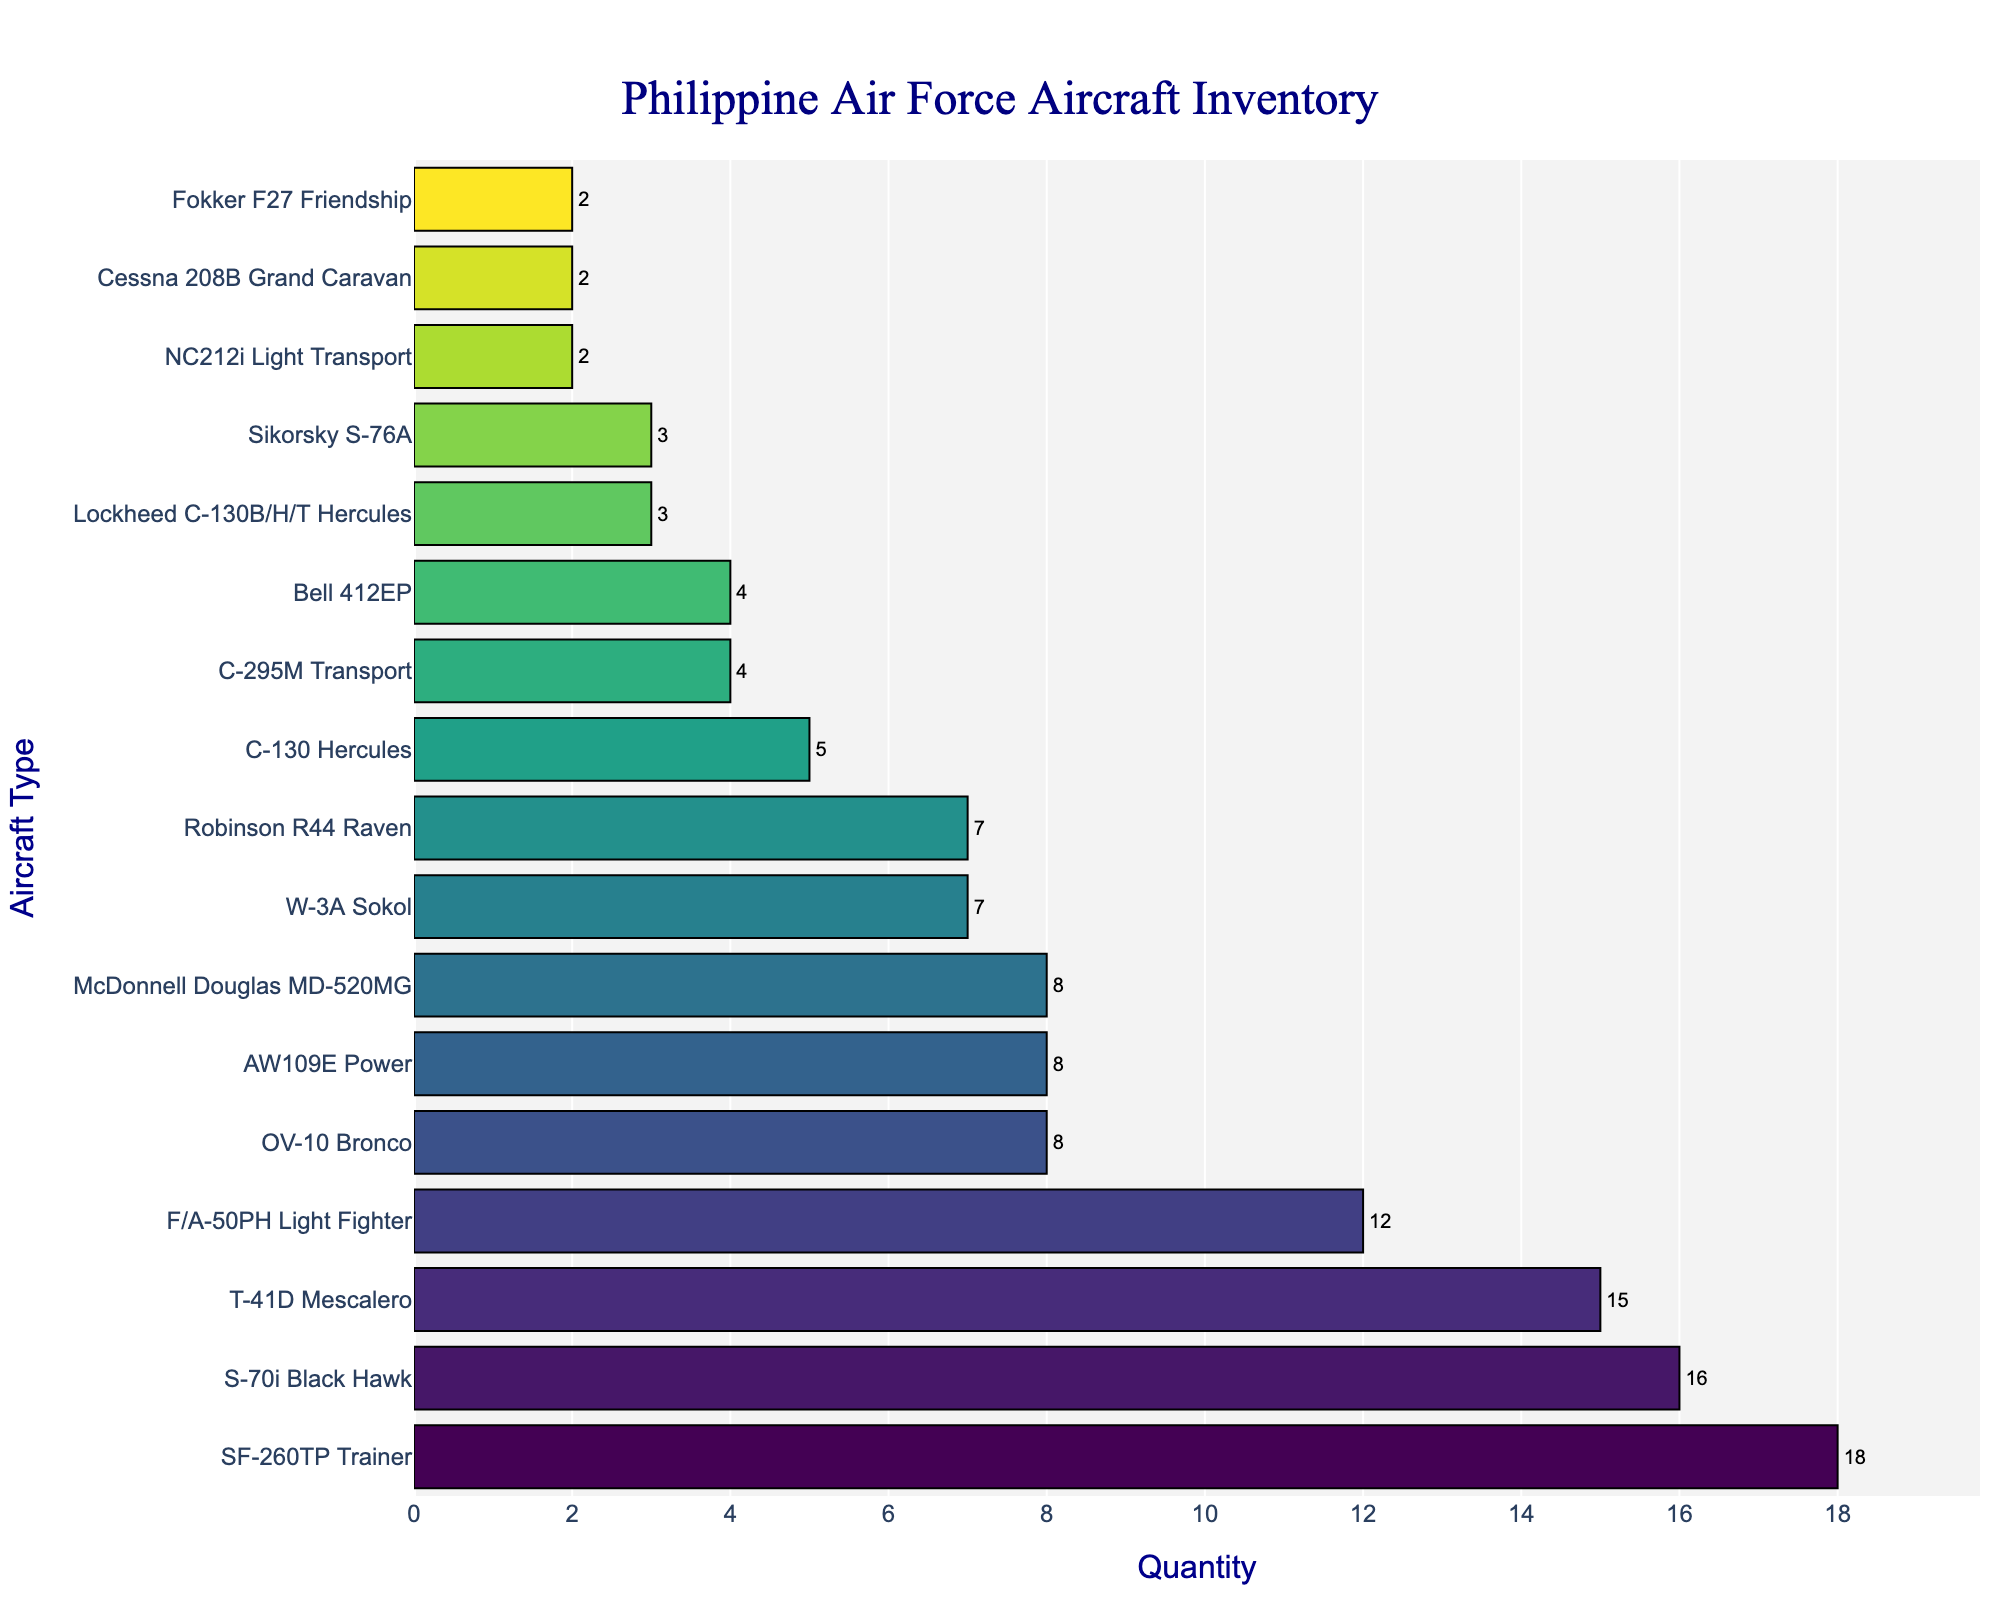What is the total number of SF-260TP Trainers and T-41D Mescaleros? The figure shows the quantity of each aircraft type. The SF-260TP Trainers have a quantity of 18, and the T-41D Mescaleros have a quantity of 15. By summing these numbers (18 + 15), we find the total is 33.
Answer: 33 Which aircraft type has the highest quantity? By observing the heights of the bars, the SF-260TP Trainer has the longest bar, indicating it has the highest quantity among the types.
Answer: SF-260TP Trainer How many more S-70i Black Hawks are there compared to C-295M Transports? The S-70i Black Hawk has a quantity of 16, and the C-295M Transport has a quantity of 4. The difference between the two quantities is 16 - 4 = 12.
Answer: 12 What is the average quantity of the top three aircraft types? The top three aircraft types by quantity are SF-260TP Trainer (18), T-41D Mescalero (15), and S-70i Black Hawk (16). Sum these quantities (18 + 15 + 16 = 49) and divide by 3 to get the average: 49 / 3 ≈ 16.33.
Answer: 16.33 Which has more aircraft: the combined total of F/A-50PH Light Fighters and AW109E Powers or the combined total of OV-10 Broncos and McDonnell Douglas MD-520MGs? F/A-50PH Light Fighters have 12, and AW109E Powers have 8. The sum is 12 + 8 = 20. OV-10 Broncos have 8, and McDonnell Douglas MD-520MGs have 8. The sum is 8 + 8 = 16. Comparing these sums, 20 is greater than 16.
Answer: Combined total of F/A-50PH Light Fighters and AW109E Powers What is the total quantity of all aircraft types displayed? Sum the quantities of all aircraft types: 12 + 16 + 8 + 7 + 4 + 5 + 2 + 8 + 18 + 15 + 7 + 2 + 2 + 3 + 4 + 8 + 3 = 116.
Answer: 116 Are there more Bell 412EPs or Sikorsky S-76As? The quantity of Bell 412EPs is 4 and Sikorsky S-76As is 3. Since 4 is greater than 3, there are more Bell 412EPs.
Answer: Bell 412EPs Which aircraft type has the smallest quantity? By observing the figure, Cessna 208B Grand Caravan, Fokker F27 Friendship, and NC212i Light Transport have the smallest bars with equal quantities of 2 each.
Answer: Cessna 208B Grand Caravan, Fokker F27 Friendship, and NC212i Light Transport How much larger is the quantity of SF-260TP Trainers compared to the quantity of Robinson R44 Ravens? The quantity of SF-260TP Trainers is 18, and the Robinson R44 Ravens have a quantity of 7. The difference is 18 - 7 = 11.
Answer: 11 Which of the following aircraft types has the exact same quantity: OV-10 Bronco, AW109E Power, and McDonnell Douglas MD-520MG? Upon comparing the bar lengths and quantities, OV-10 Bronco and McDonnell Douglas MD-520MG both have a quantity of 8, which is the same quantity as AW109E Power.
Answer: OV-10 Bronco and McDonnell Douglas MD-520MG 